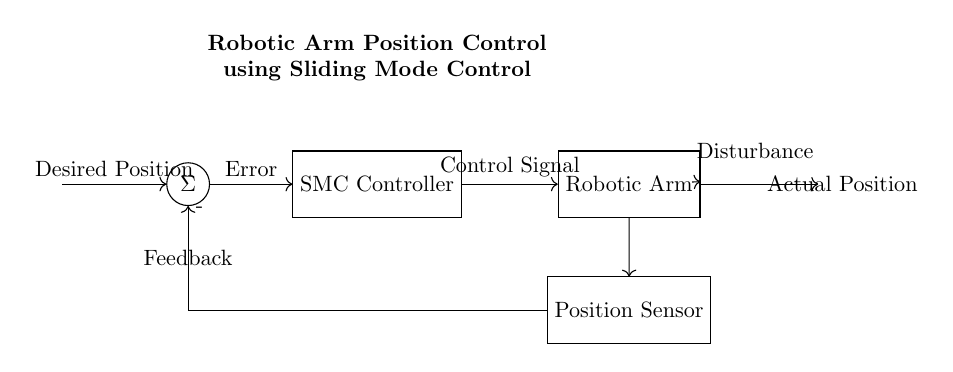What is the output of the system? The output represents the actual position of the robotic arm, which is shown as the output node directly connected to the robotic arm block.
Answer: Actual Position What sends feedback to the sum node? Feedback is provided by the position sensor that detects the actual position of the robotic arm and sends it back to the sum node to compare with the desired position.
Answer: Position Sensor What type of controller is used in this circuit? The controller specified in the circuit diagram is a Sliding Mode Controller, indicated by the label on the block connected to the sum node.
Answer: SMC Controller What does the sum node represent in this control system? The sum node is responsible for calculating the error by subtracting the actual position from the desired position, which is essential for feedback control.
Answer: Error What disturbance is indicated in the circuit? The disturbance represented in the diagram is an external factor affecting the robotic arm system, denoted by an arrow pointing to the robotic arm block, which could influence its performance.
Answer: Disturbance What signal does the controller output to the system? The control signal produced by the SMC Controller is sent to the robotic arm, which dictates its movement to achieve the desired position.
Answer: Control Signal 